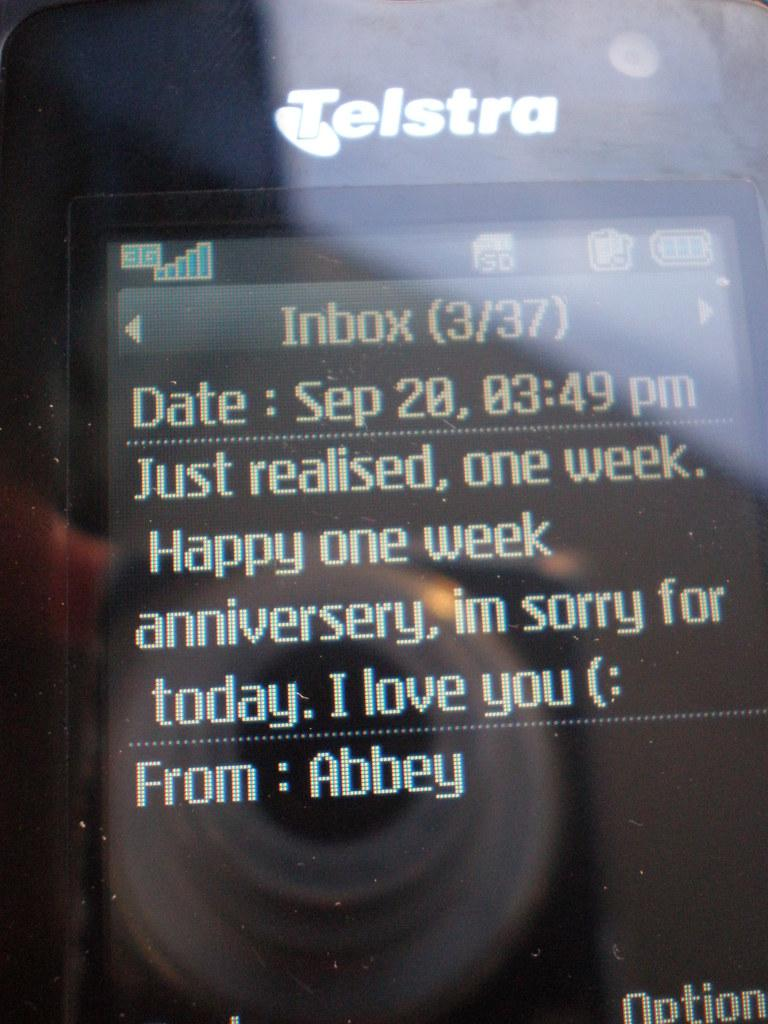Provide a one-sentence caption for the provided image. A text message that expresses an apology and wish the recipient a Happy one week anniversary. 